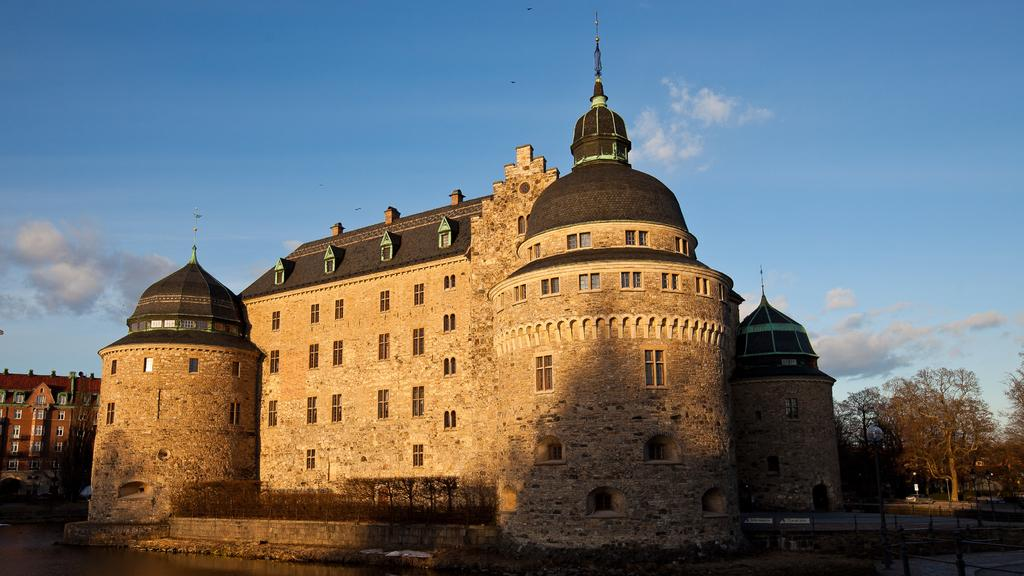What type of structures can be seen in the image? There are buildings in the image. What is located on the right side of the image? There are trees on the right side of the image. What is visible at the top of the image? The sky is visible at the top of the image. Can you see your dad flying an airplane in the image? There is no airplane or person resembling a dad present in the image. What is being pushed in the image? There is no object being pushed in the image. 